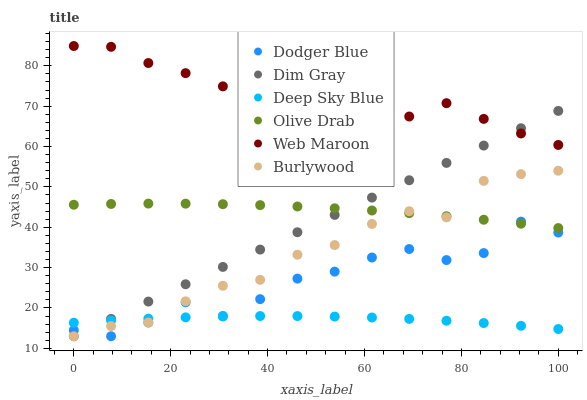Does Deep Sky Blue have the minimum area under the curve?
Answer yes or no. Yes. Does Web Maroon have the maximum area under the curve?
Answer yes or no. Yes. Does Burlywood have the minimum area under the curve?
Answer yes or no. No. Does Burlywood have the maximum area under the curve?
Answer yes or no. No. Is Dim Gray the smoothest?
Answer yes or no. Yes. Is Web Maroon the roughest?
Answer yes or no. Yes. Is Burlywood the smoothest?
Answer yes or no. No. Is Burlywood the roughest?
Answer yes or no. No. Does Dim Gray have the lowest value?
Answer yes or no. Yes. Does Web Maroon have the lowest value?
Answer yes or no. No. Does Web Maroon have the highest value?
Answer yes or no. Yes. Does Burlywood have the highest value?
Answer yes or no. No. Is Burlywood less than Web Maroon?
Answer yes or no. Yes. Is Web Maroon greater than Deep Sky Blue?
Answer yes or no. Yes. Does Dim Gray intersect Deep Sky Blue?
Answer yes or no. Yes. Is Dim Gray less than Deep Sky Blue?
Answer yes or no. No. Is Dim Gray greater than Deep Sky Blue?
Answer yes or no. No. Does Burlywood intersect Web Maroon?
Answer yes or no. No. 